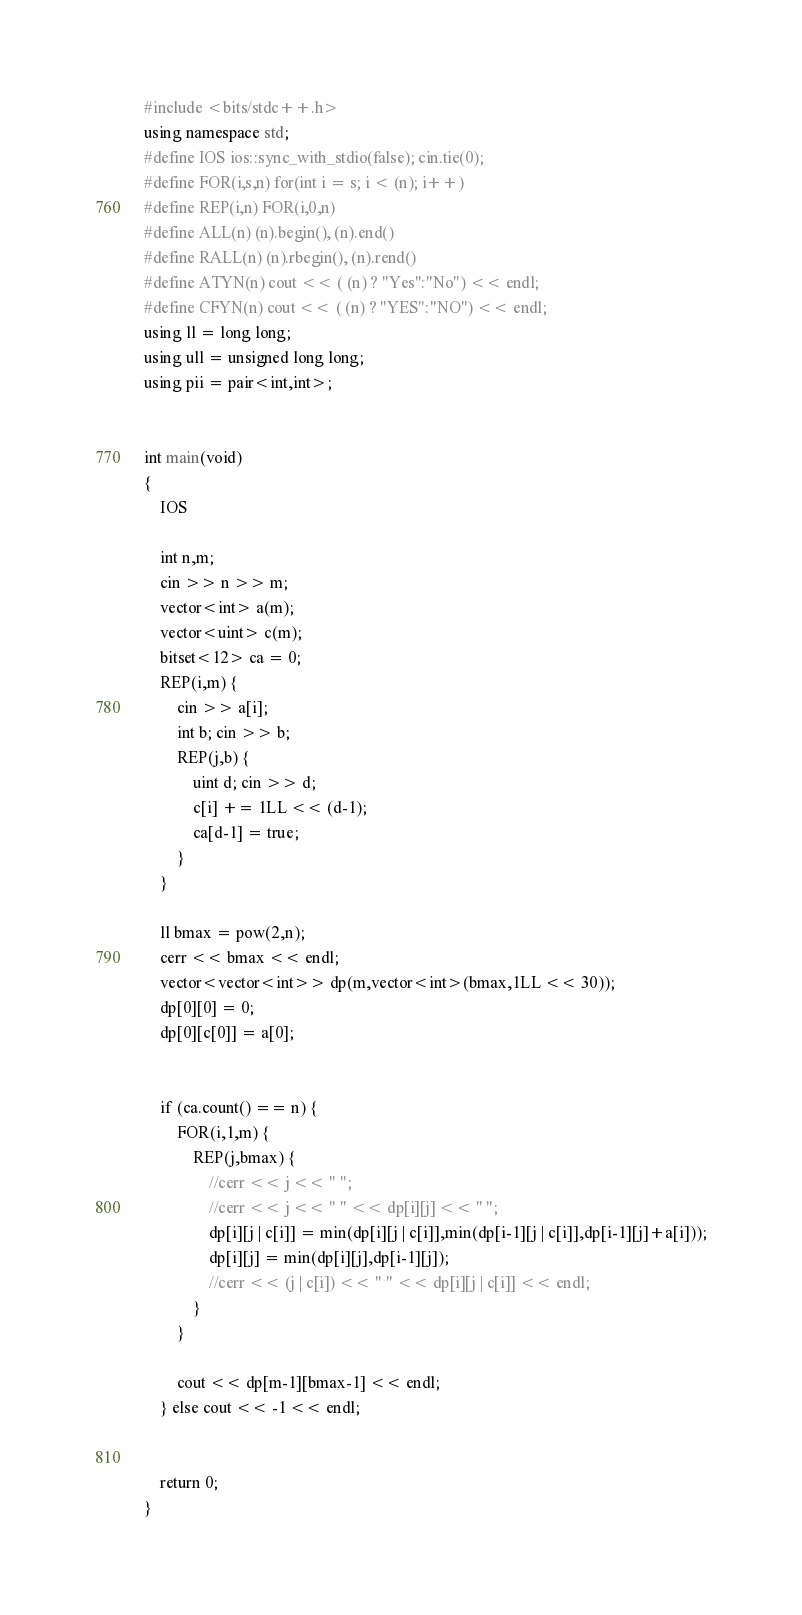<code> <loc_0><loc_0><loc_500><loc_500><_C++_>#include <bits/stdc++.h>
using namespace std;
#define IOS ios::sync_with_stdio(false); cin.tie(0);
#define FOR(i,s,n) for(int i = s; i < (n); i++)
#define REP(i,n) FOR(i,0,n)
#define ALL(n) (n).begin(), (n).end()
#define RALL(n) (n).rbegin(), (n).rend()
#define ATYN(n) cout << ( (n) ? "Yes":"No") << endl;
#define CFYN(n) cout << ( (n) ? "YES":"NO") << endl;
using ll = long long;
using ull = unsigned long long;
using pii = pair<int,int>;


int main(void)
{
    IOS

    int n,m;
    cin >> n >> m;
    vector<int> a(m);
    vector<uint> c(m);
    bitset<12> ca = 0;
    REP(i,m) {
        cin >> a[i];
        int b; cin >> b;
        REP(j,b) {
            uint d; cin >> d;
            c[i] += 1LL << (d-1);
            ca[d-1] = true;
        }
    }

    ll bmax = pow(2,n);
    cerr << bmax << endl;
    vector<vector<int>> dp(m,vector<int>(bmax,1LL << 30)); 
    dp[0][0] = 0;
    dp[0][c[0]] = a[0];


    if (ca.count() == n) {
        FOR(i,1,m) {
            REP(j,bmax) {
                //cerr << j << " ";
                //cerr << j << " " << dp[i][j] << " ";
                dp[i][j | c[i]] = min(dp[i][j | c[i]],min(dp[i-1][j | c[i]],dp[i-1][j]+a[i]));
                dp[i][j] = min(dp[i][j],dp[i-1][j]);
                //cerr << (j | c[i]) << " " << dp[i][j | c[i]] << endl;
            }
        }

        cout << dp[m-1][bmax-1] << endl;
    } else cout << -1 << endl;


    return 0;
}</code> 